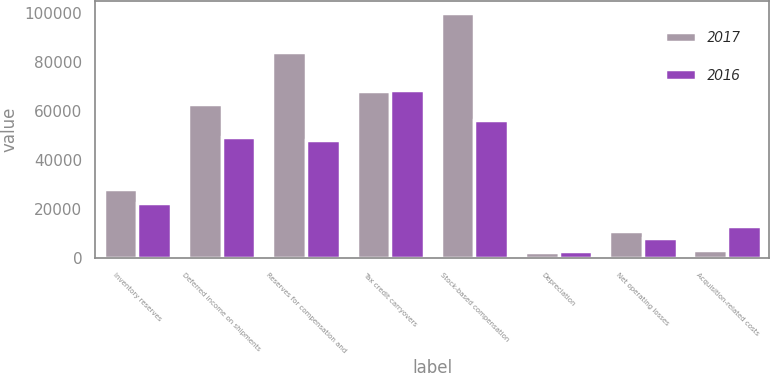Convert chart. <chart><loc_0><loc_0><loc_500><loc_500><stacked_bar_chart><ecel><fcel>Inventory reserves<fcel>Deferred income on shipments<fcel>Reserves for compensation and<fcel>Tax credit carryovers<fcel>Stock-based compensation<fcel>Depreciation<fcel>Net operating losses<fcel>Acquisition-related costs<nl><fcel>2017<fcel>28137<fcel>62923<fcel>84096<fcel>68317<fcel>99815<fcel>2659<fcel>11158<fcel>3384<nl><fcel>2016<fcel>22527<fcel>49455<fcel>48062<fcel>68669<fcel>56345<fcel>3078<fcel>8225<fcel>13336<nl></chart> 